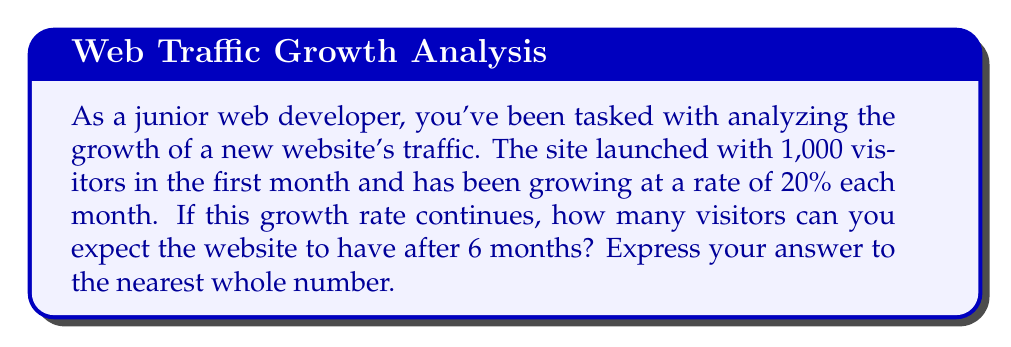Give your solution to this math problem. To solve this problem, we'll use the formula for exponential growth:

$$A = P(1 + r)^t$$

Where:
$A$ = Final amount
$P$ = Initial principal (starting amount)
$r$ = Growth rate (as a decimal)
$t$ = Time periods

Given:
$P = 1,000$ (initial visitors)
$r = 0.20$ (20% growth rate)
$t = 6$ (months)

Let's plug these values into our formula:

$$A = 1,000(1 + 0.20)^6$$

Now, let's solve step-by-step:

1) First, calculate $(1 + 0.20)$:
   $1 + 0.20 = 1.20$

2) Now, we have:
   $$A = 1,000(1.20)^6$$

3) Calculate $1.20^6$:
   $1.20^6 \approx 2.9859$

4) Multiply by 1,000:
   $1,000 * 2.9859 \approx 2,985.98$

5) Round to the nearest whole number:
   $2,985.98 \approx 2,986$

Therefore, after 6 months, you can expect the website to have approximately 2,986 visitors.
Answer: 2,986 visitors 